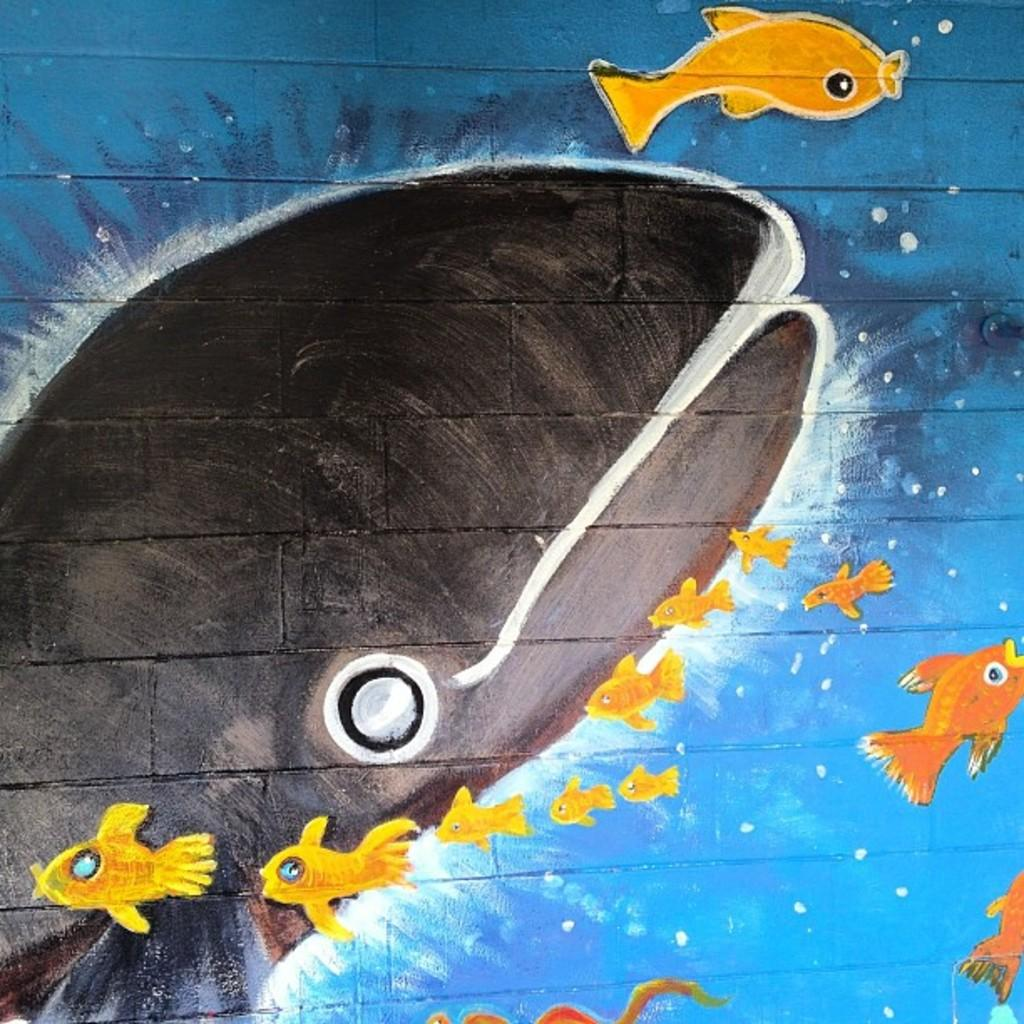What is on the wall in the image? There is a painting on the wall in the image. What is the subject of the painting? The painting depicts fishes in the water. Where is the nearest airport to the painting in the image? The provided facts do not mention any location or context for the image, so it is impossible to determine the nearest airport. 